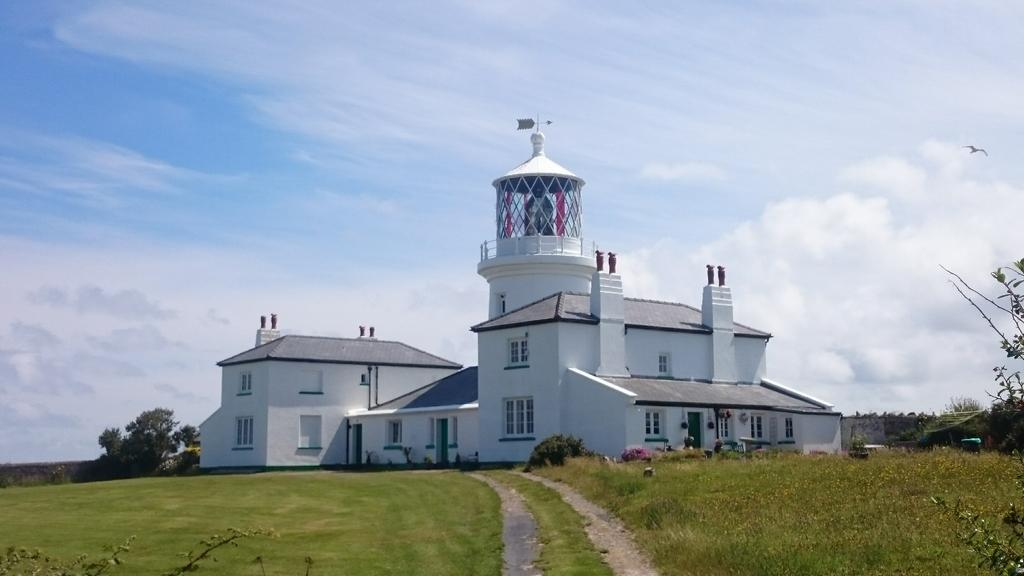What type of structure is visible in the image? There is a house in the image. What pathway can be seen in the image? There is a walkway in the image. What type of vegetation is present in the image? There is grass in the image. What can be seen in the background of the image? There are trees and a clear sky in the background of the image. What committee is meeting in the field in the image? There is no committee or field present in the image; it features a house, walkway, grass, trees, and a clear sky. What is the temperature in the image? The provided facts do not mention the temperature or heat in the image. 